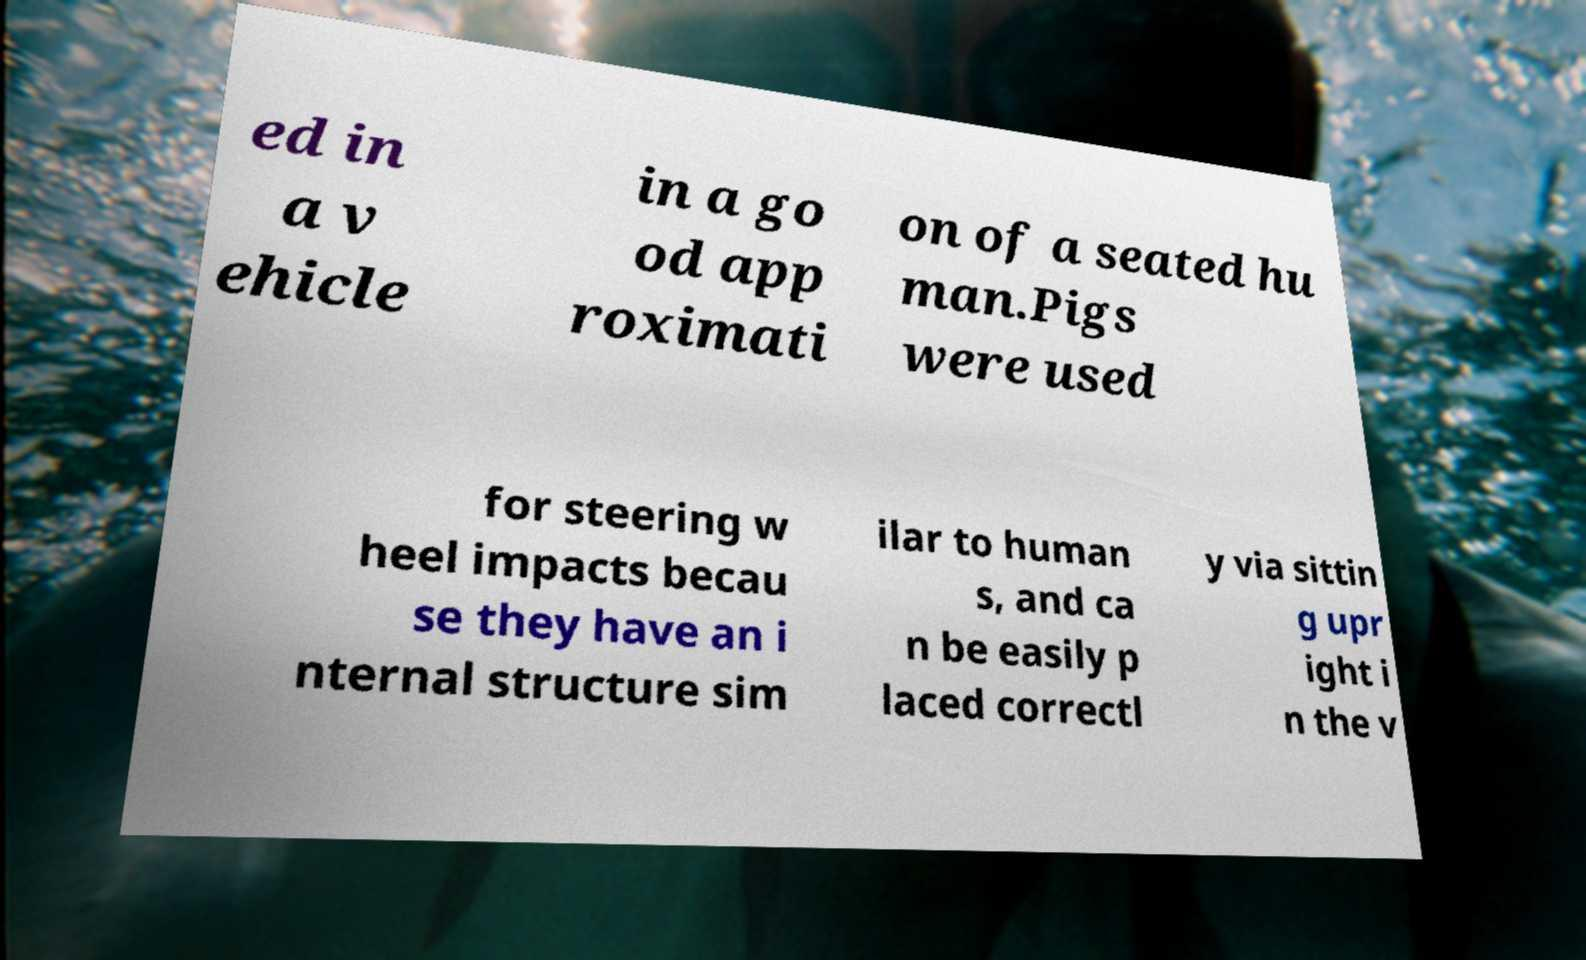For documentation purposes, I need the text within this image transcribed. Could you provide that? ed in a v ehicle in a go od app roximati on of a seated hu man.Pigs were used for steering w heel impacts becau se they have an i nternal structure sim ilar to human s, and ca n be easily p laced correctl y via sittin g upr ight i n the v 